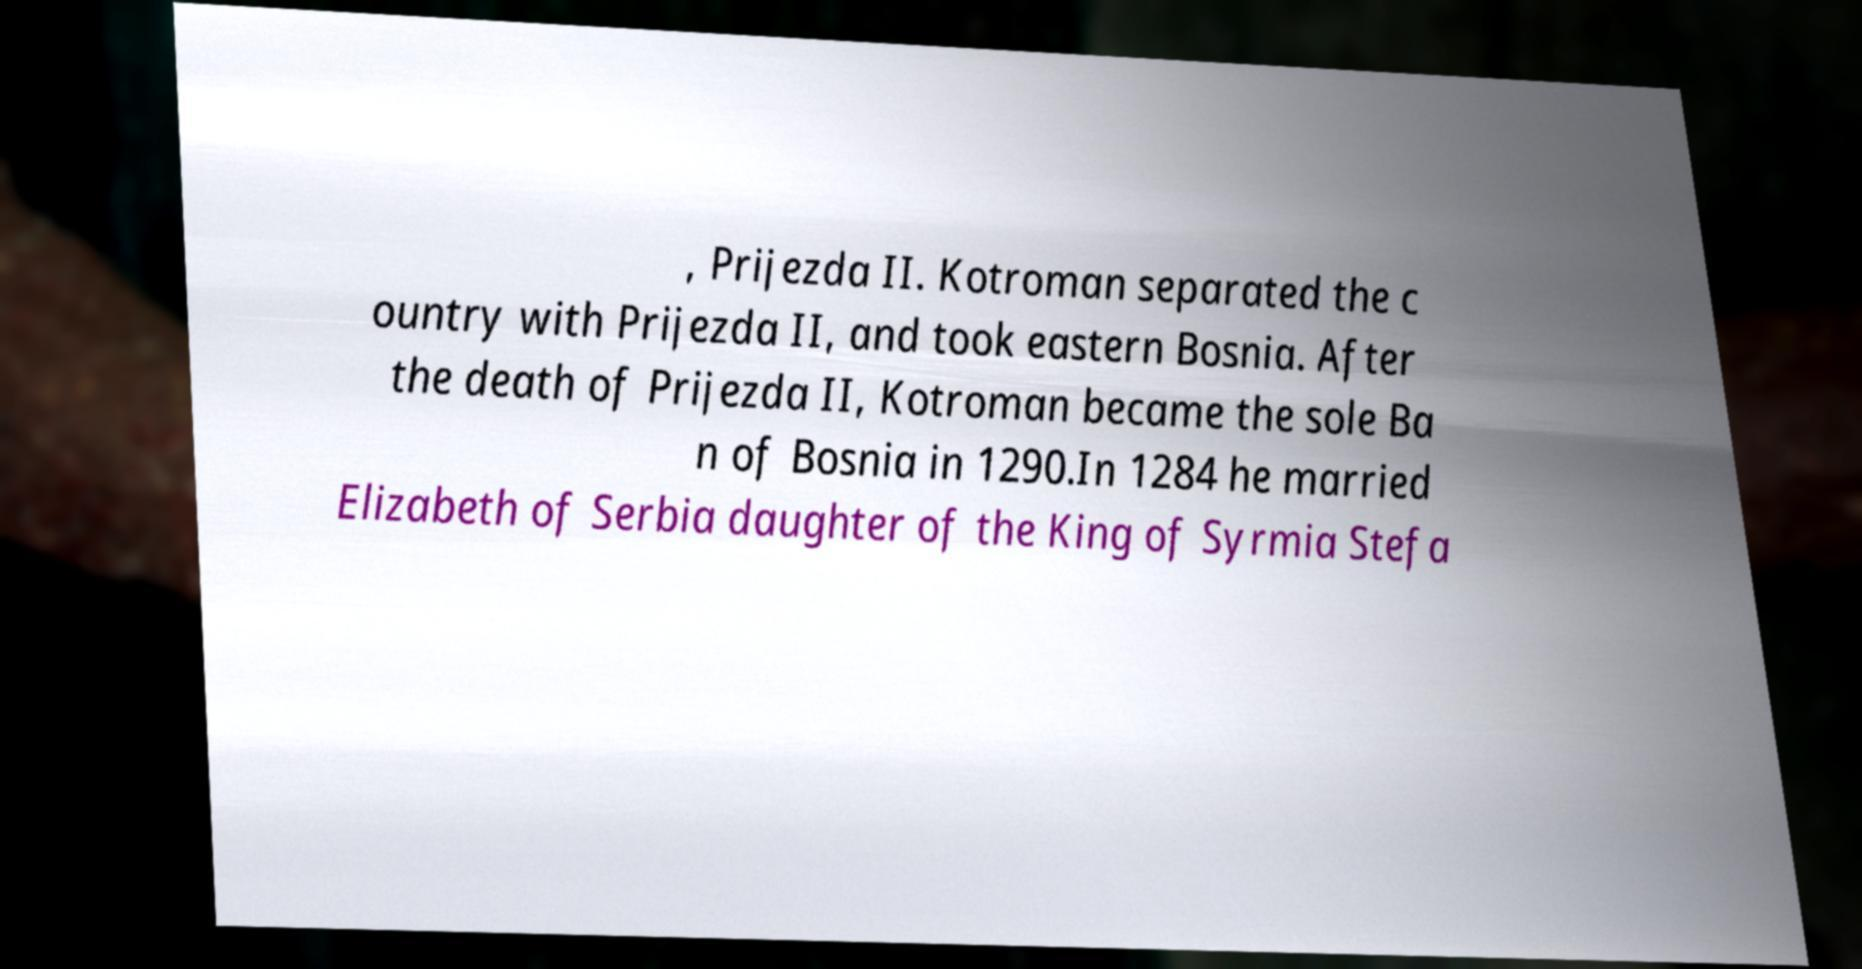Can you read and provide the text displayed in the image?This photo seems to have some interesting text. Can you extract and type it out for me? , Prijezda II. Kotroman separated the c ountry with Prijezda II, and took eastern Bosnia. After the death of Prijezda II, Kotroman became the sole Ba n of Bosnia in 1290.In 1284 he married Elizabeth of Serbia daughter of the King of Syrmia Stefa 